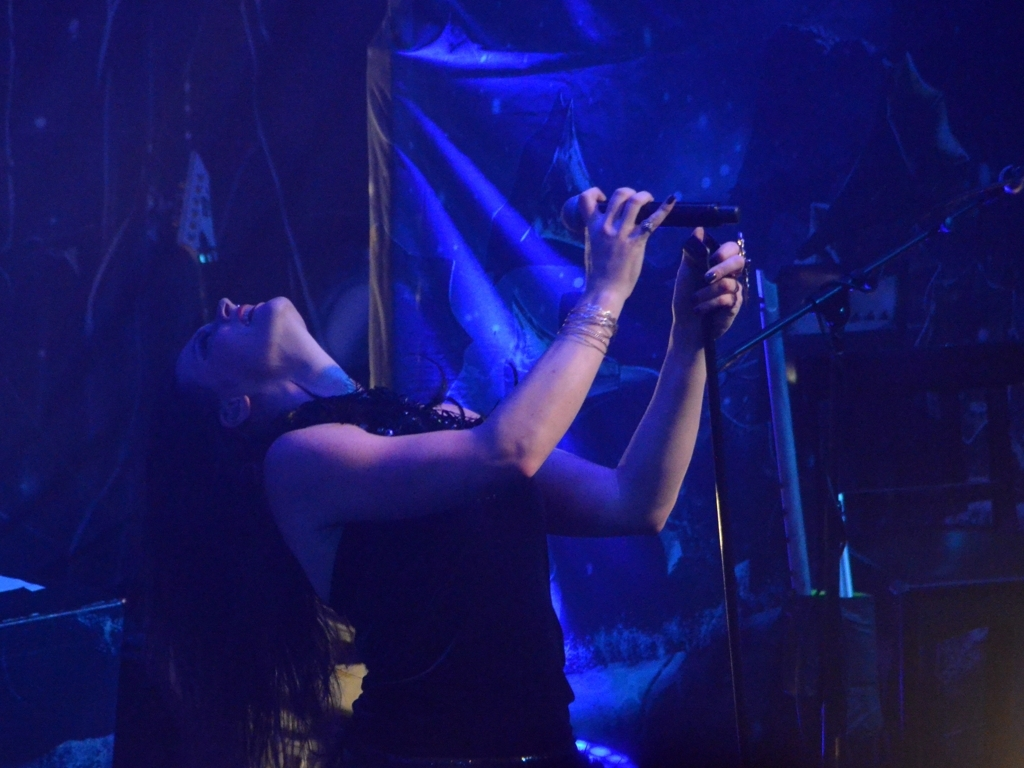Can you describe the style of the performer? The performer appears to have a gothic or alternative style, with a black outfit adorned with intricate details, and their passionate performance stance indicates a strong connection to the music. 